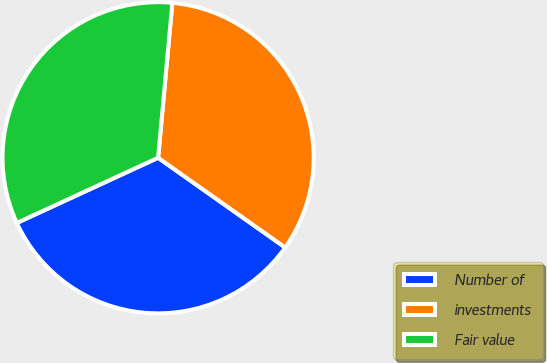Convert chart to OTSL. <chart><loc_0><loc_0><loc_500><loc_500><pie_chart><fcel>Number of<fcel>investments<fcel>Fair value<nl><fcel>33.34%<fcel>33.32%<fcel>33.34%<nl></chart> 